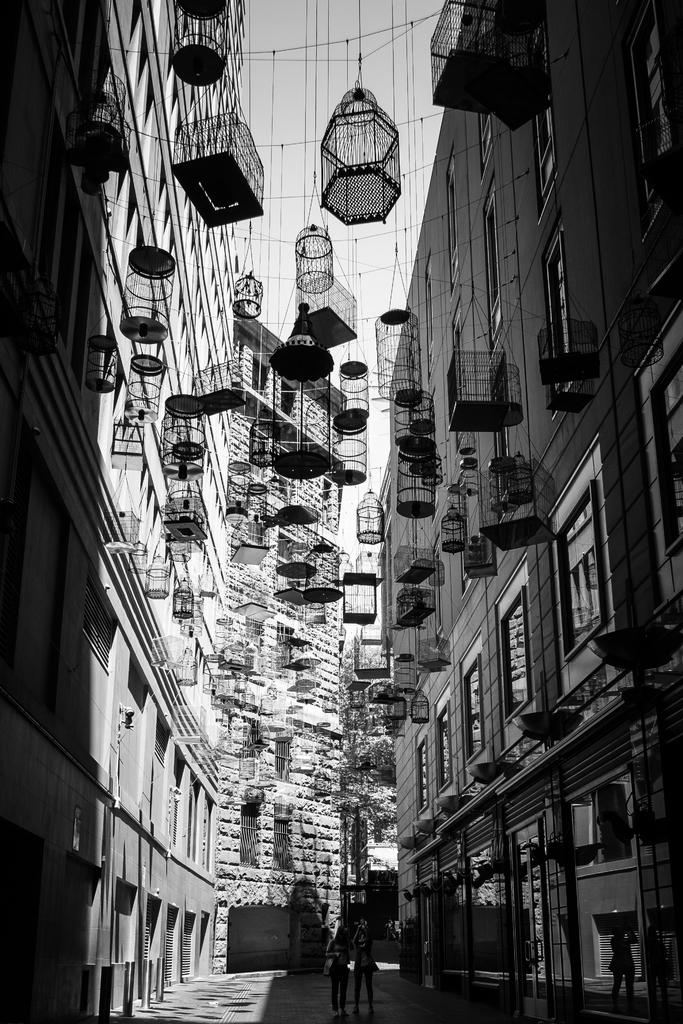What type of structures can be seen in the image? There are buildings in the image. What objects are related to birds in the image? There are bird cages in the image. What are the people in the image doing? The people are standing on the ground in the image. What is the color scheme of the image? The image is black and white in color. What can be seen in the background of the image? The sky is visible in the background of the image. What type of impulse can be seen affecting the church in the image? There is no church present in the image, so it is not possible to determine if any impulse is affecting it. How does the rainstorm affect the people in the image? There is no rainstorm present in the image, so it is not possible to determine how it would affect the people. 